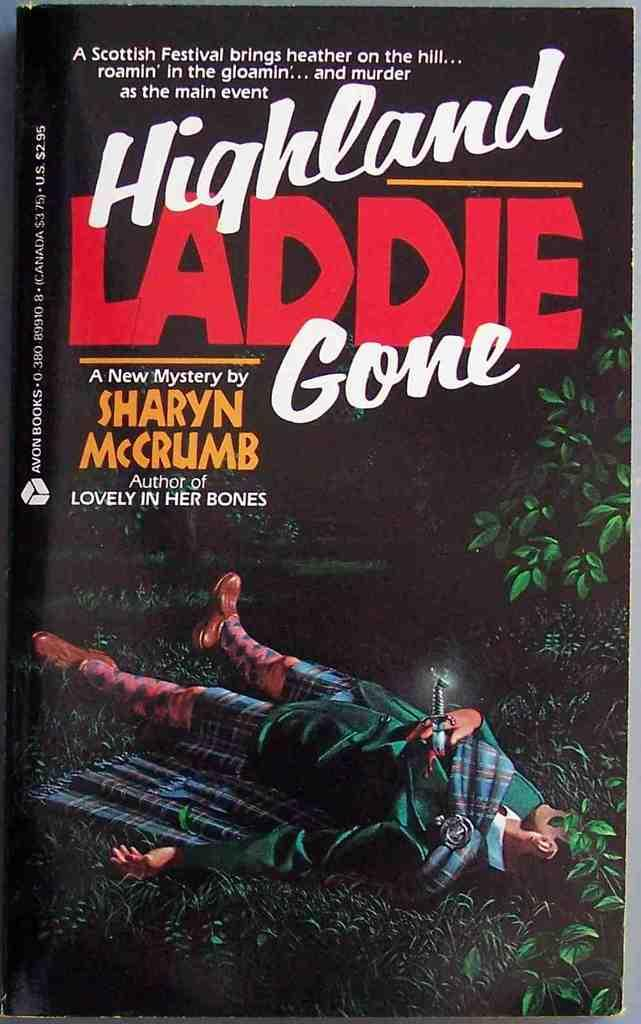What is the main subject of the image? There is a depiction of a person in the image. Are there any words or letters in the image? Yes, there is text in the image. What type of vegetation is on the right side of the image? There are plants on the right side of the image. Can you tell me how many toads are sitting on the person's shoulder in the image? There are no toads present in the image; it features a depiction of a person and text, with plants on the right side. Who is the creator of the person depicted in the image? The facts provided do not give any information about the creator of the person depicted in the image. 